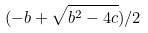Convert formula to latex. <formula><loc_0><loc_0><loc_500><loc_500>( - b + \sqrt { b ^ { 2 } - 4 c } ) / 2</formula> 